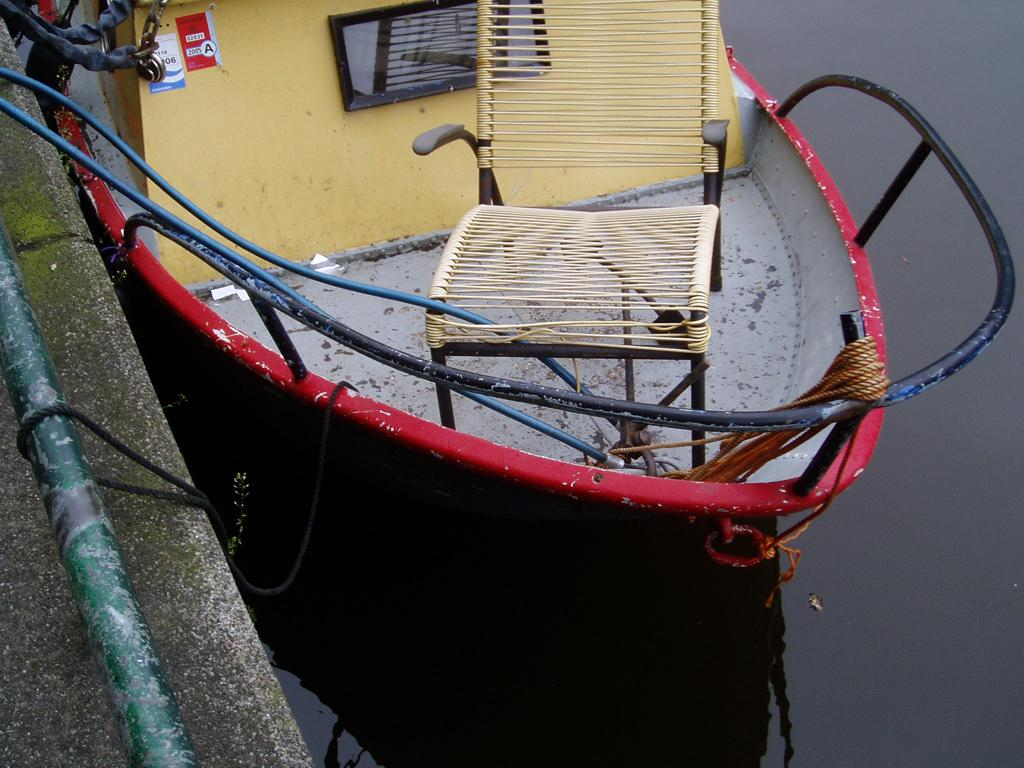What is the main subject in the image? There is a boat in the image. Where is the boat located? The boat is on the water surface. What type of appliance is present in the image? There is no appliance present in the image; it only features a boat on the water surface. 